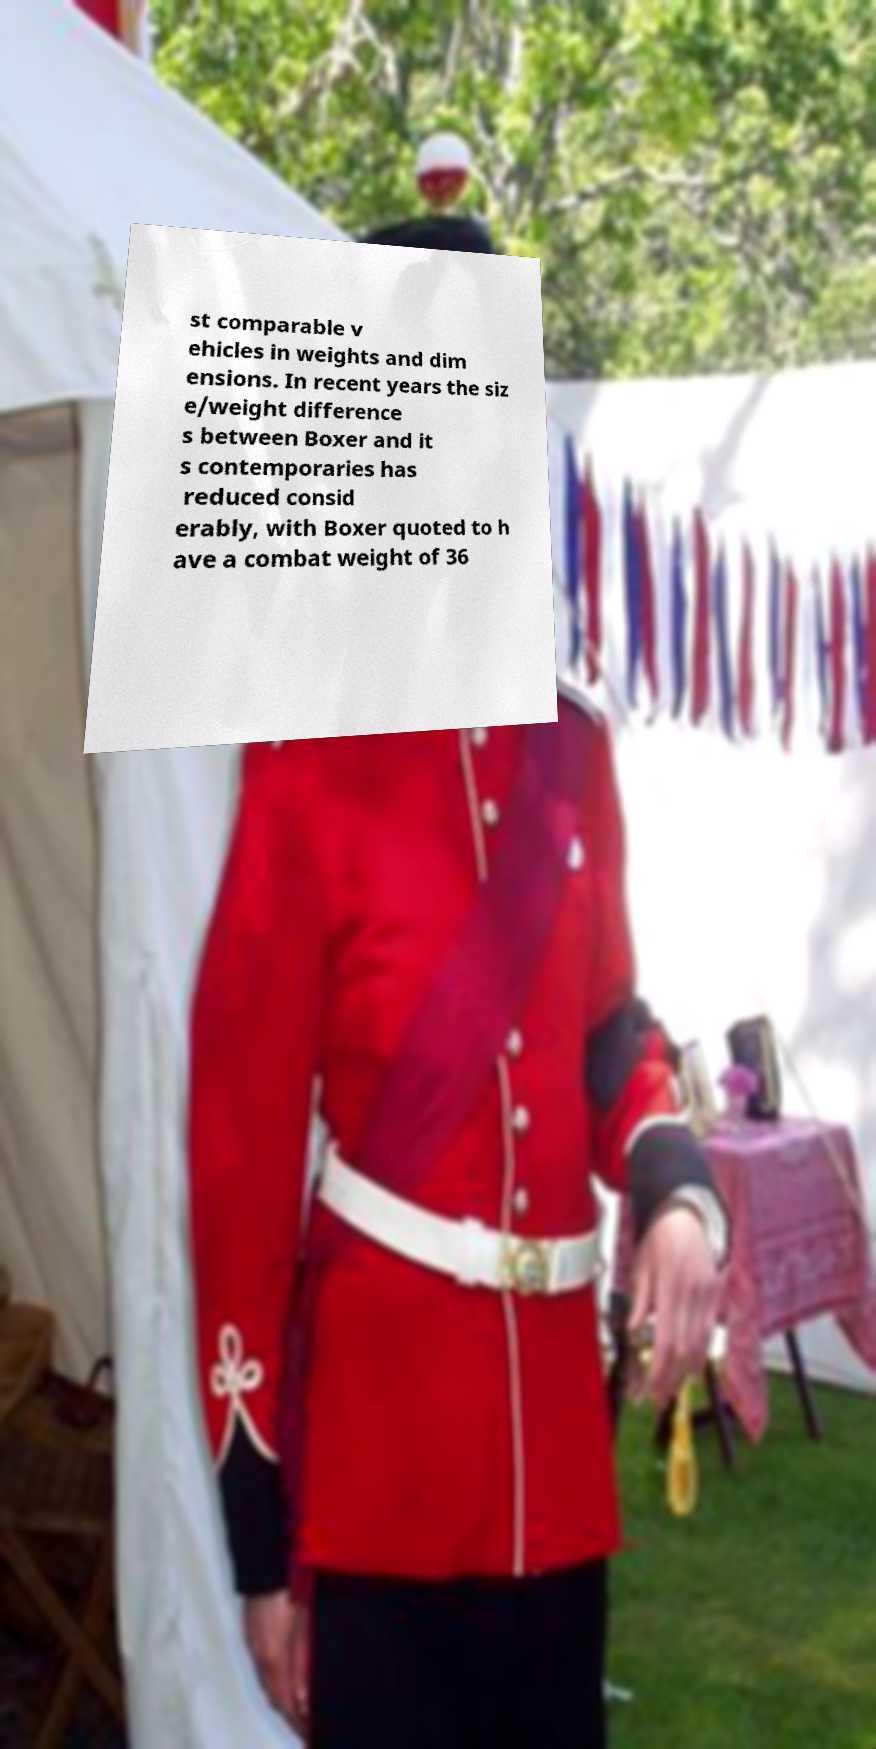Please read and relay the text visible in this image. What does it say? st comparable v ehicles in weights and dim ensions. In recent years the siz e/weight difference s between Boxer and it s contemporaries has reduced consid erably, with Boxer quoted to h ave a combat weight of 36 